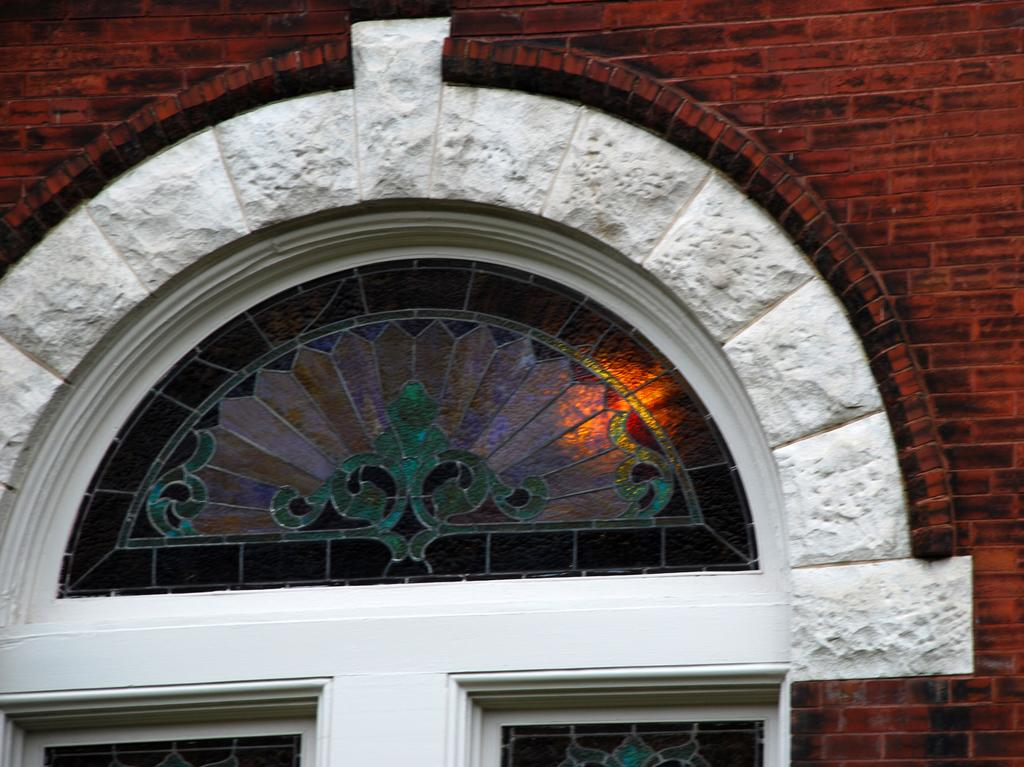What is the main subject of the image? The main subject of the image is a window of a building. What material is the wall made of? A: The wall is made up of bricks. What is present in the front of the image? There is a glass in the front of the image. Can you see the son eating a grape with a smile in the image? There is no son, grape, or smile present in the image; it only features a window of a building with a brick wall and a glass in the front. 